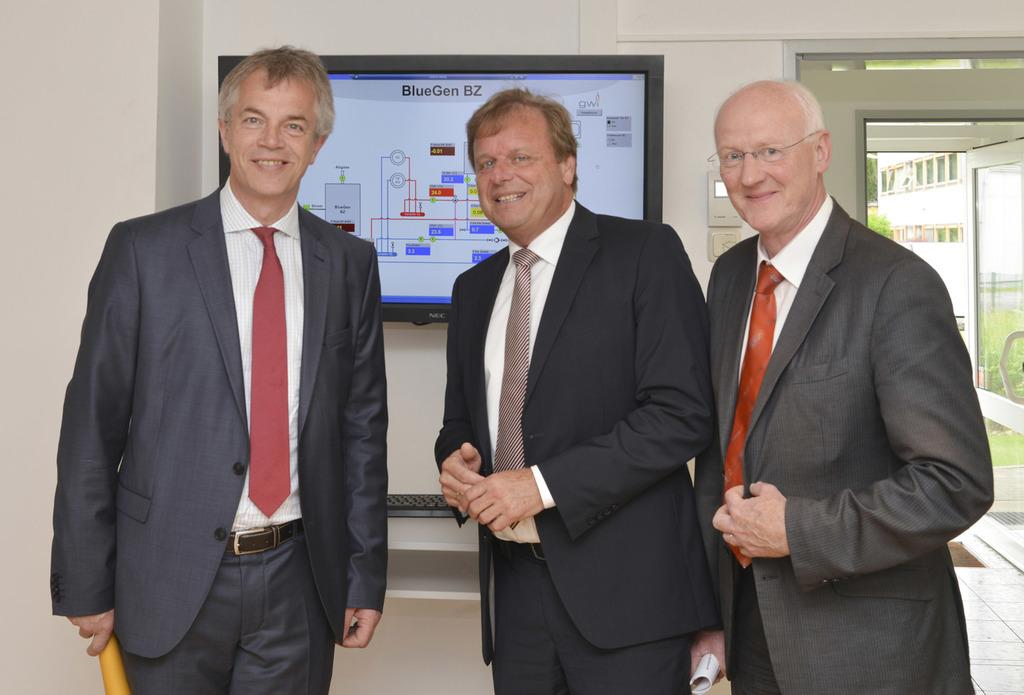How many people are present in the image? There are three persons standing in the image. What are the persons holding in the image? The persons are holding a paper. Can you describe the background of the image? There is a wall with a TV and a keyboard in the background, along with a door, a building, and trees. What is the record for the most interest in a single topic in the image? There is no record or indication of interest in any topic in the image. 